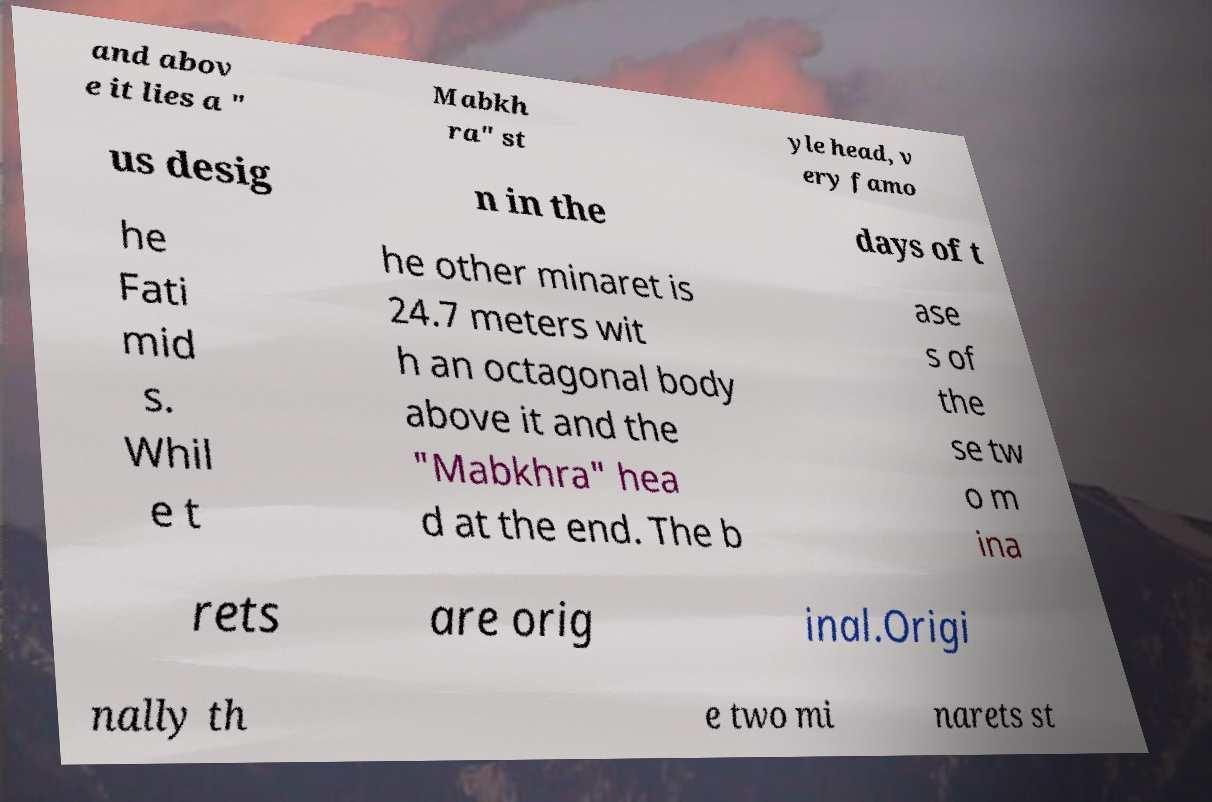Could you assist in decoding the text presented in this image and type it out clearly? and abov e it lies a " Mabkh ra" st yle head, v ery famo us desig n in the days of t he Fati mid s. Whil e t he other minaret is 24.7 meters wit h an octagonal body above it and the "Mabkhra" hea d at the end. The b ase s of the se tw o m ina rets are orig inal.Origi nally th e two mi narets st 